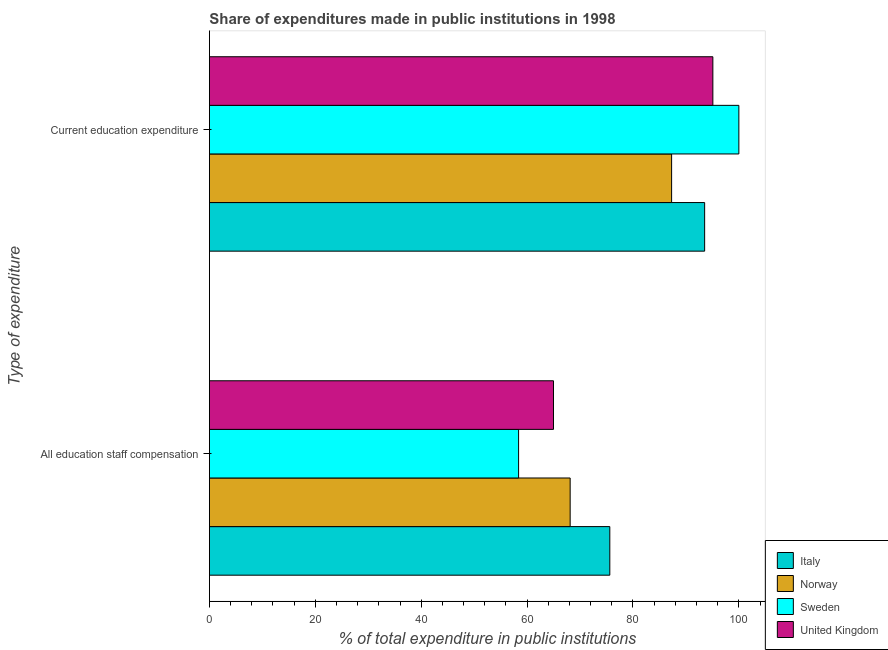How many groups of bars are there?
Your response must be concise. 2. How many bars are there on the 1st tick from the top?
Your answer should be very brief. 4. How many bars are there on the 2nd tick from the bottom?
Provide a short and direct response. 4. What is the label of the 2nd group of bars from the top?
Offer a very short reply. All education staff compensation. What is the expenditure in education in United Kingdom?
Make the answer very short. 95.09. Across all countries, what is the minimum expenditure in education?
Your response must be concise. 87.3. In which country was the expenditure in education minimum?
Your answer should be very brief. Norway. What is the total expenditure in staff compensation in the graph?
Make the answer very short. 267.14. What is the difference between the expenditure in staff compensation in Italy and that in United Kingdom?
Your answer should be very brief. 10.64. What is the difference between the expenditure in staff compensation in Italy and the expenditure in education in Sweden?
Provide a short and direct response. -24.37. What is the average expenditure in education per country?
Provide a succinct answer. 93.98. What is the difference between the expenditure in education and expenditure in staff compensation in Italy?
Your answer should be very brief. 17.91. What is the ratio of the expenditure in education in Norway to that in United Kingdom?
Provide a short and direct response. 0.92. Is the expenditure in education in Italy less than that in Norway?
Your answer should be compact. No. What does the 1st bar from the top in Current education expenditure represents?
Provide a short and direct response. United Kingdom. What does the 3rd bar from the bottom in Current education expenditure represents?
Your answer should be very brief. Sweden. How many countries are there in the graph?
Your response must be concise. 4. Are the values on the major ticks of X-axis written in scientific E-notation?
Your response must be concise. No. Does the graph contain any zero values?
Your answer should be compact. No. Does the graph contain grids?
Make the answer very short. No. Where does the legend appear in the graph?
Give a very brief answer. Bottom right. How many legend labels are there?
Ensure brevity in your answer.  4. How are the legend labels stacked?
Ensure brevity in your answer.  Vertical. What is the title of the graph?
Ensure brevity in your answer.  Share of expenditures made in public institutions in 1998. What is the label or title of the X-axis?
Ensure brevity in your answer.  % of total expenditure in public institutions. What is the label or title of the Y-axis?
Your answer should be compact. Type of expenditure. What is the % of total expenditure in public institutions of Italy in All education staff compensation?
Offer a terse response. 75.63. What is the % of total expenditure in public institutions in Norway in All education staff compensation?
Your answer should be compact. 68.14. What is the % of total expenditure in public institutions in Sweden in All education staff compensation?
Give a very brief answer. 58.4. What is the % of total expenditure in public institutions in United Kingdom in All education staff compensation?
Your response must be concise. 64.98. What is the % of total expenditure in public institutions in Italy in Current education expenditure?
Provide a short and direct response. 93.54. What is the % of total expenditure in public institutions of Norway in Current education expenditure?
Make the answer very short. 87.3. What is the % of total expenditure in public institutions in Sweden in Current education expenditure?
Keep it short and to the point. 100. What is the % of total expenditure in public institutions in United Kingdom in Current education expenditure?
Offer a terse response. 95.09. Across all Type of expenditure, what is the maximum % of total expenditure in public institutions of Italy?
Ensure brevity in your answer.  93.54. Across all Type of expenditure, what is the maximum % of total expenditure in public institutions of Norway?
Provide a short and direct response. 87.3. Across all Type of expenditure, what is the maximum % of total expenditure in public institutions in Sweden?
Keep it short and to the point. 100. Across all Type of expenditure, what is the maximum % of total expenditure in public institutions of United Kingdom?
Provide a succinct answer. 95.09. Across all Type of expenditure, what is the minimum % of total expenditure in public institutions of Italy?
Your response must be concise. 75.63. Across all Type of expenditure, what is the minimum % of total expenditure in public institutions in Norway?
Make the answer very short. 68.14. Across all Type of expenditure, what is the minimum % of total expenditure in public institutions in Sweden?
Keep it short and to the point. 58.4. Across all Type of expenditure, what is the minimum % of total expenditure in public institutions in United Kingdom?
Offer a very short reply. 64.98. What is the total % of total expenditure in public institutions of Italy in the graph?
Provide a short and direct response. 169.16. What is the total % of total expenditure in public institutions of Norway in the graph?
Your response must be concise. 155.43. What is the total % of total expenditure in public institutions of Sweden in the graph?
Provide a succinct answer. 158.4. What is the total % of total expenditure in public institutions in United Kingdom in the graph?
Your answer should be very brief. 160.07. What is the difference between the % of total expenditure in public institutions in Italy in All education staff compensation and that in Current education expenditure?
Keep it short and to the point. -17.91. What is the difference between the % of total expenditure in public institutions of Norway in All education staff compensation and that in Current education expenditure?
Provide a short and direct response. -19.16. What is the difference between the % of total expenditure in public institutions in Sweden in All education staff compensation and that in Current education expenditure?
Make the answer very short. -41.6. What is the difference between the % of total expenditure in public institutions in United Kingdom in All education staff compensation and that in Current education expenditure?
Your response must be concise. -30.1. What is the difference between the % of total expenditure in public institutions in Italy in All education staff compensation and the % of total expenditure in public institutions in Norway in Current education expenditure?
Give a very brief answer. -11.67. What is the difference between the % of total expenditure in public institutions in Italy in All education staff compensation and the % of total expenditure in public institutions in Sweden in Current education expenditure?
Your response must be concise. -24.37. What is the difference between the % of total expenditure in public institutions of Italy in All education staff compensation and the % of total expenditure in public institutions of United Kingdom in Current education expenditure?
Offer a very short reply. -19.46. What is the difference between the % of total expenditure in public institutions in Norway in All education staff compensation and the % of total expenditure in public institutions in Sweden in Current education expenditure?
Provide a short and direct response. -31.86. What is the difference between the % of total expenditure in public institutions of Norway in All education staff compensation and the % of total expenditure in public institutions of United Kingdom in Current education expenditure?
Provide a succinct answer. -26.95. What is the difference between the % of total expenditure in public institutions in Sweden in All education staff compensation and the % of total expenditure in public institutions in United Kingdom in Current education expenditure?
Provide a short and direct response. -36.69. What is the average % of total expenditure in public institutions in Italy per Type of expenditure?
Ensure brevity in your answer.  84.58. What is the average % of total expenditure in public institutions in Norway per Type of expenditure?
Offer a terse response. 77.72. What is the average % of total expenditure in public institutions in Sweden per Type of expenditure?
Keep it short and to the point. 79.2. What is the average % of total expenditure in public institutions of United Kingdom per Type of expenditure?
Your answer should be compact. 80.04. What is the difference between the % of total expenditure in public institutions in Italy and % of total expenditure in public institutions in Norway in All education staff compensation?
Your answer should be very brief. 7.49. What is the difference between the % of total expenditure in public institutions in Italy and % of total expenditure in public institutions in Sweden in All education staff compensation?
Ensure brevity in your answer.  17.23. What is the difference between the % of total expenditure in public institutions in Italy and % of total expenditure in public institutions in United Kingdom in All education staff compensation?
Ensure brevity in your answer.  10.64. What is the difference between the % of total expenditure in public institutions in Norway and % of total expenditure in public institutions in Sweden in All education staff compensation?
Provide a succinct answer. 9.74. What is the difference between the % of total expenditure in public institutions of Norway and % of total expenditure in public institutions of United Kingdom in All education staff compensation?
Your answer should be very brief. 3.15. What is the difference between the % of total expenditure in public institutions in Sweden and % of total expenditure in public institutions in United Kingdom in All education staff compensation?
Ensure brevity in your answer.  -6.59. What is the difference between the % of total expenditure in public institutions of Italy and % of total expenditure in public institutions of Norway in Current education expenditure?
Make the answer very short. 6.24. What is the difference between the % of total expenditure in public institutions in Italy and % of total expenditure in public institutions in Sweden in Current education expenditure?
Make the answer very short. -6.46. What is the difference between the % of total expenditure in public institutions of Italy and % of total expenditure in public institutions of United Kingdom in Current education expenditure?
Ensure brevity in your answer.  -1.55. What is the difference between the % of total expenditure in public institutions in Norway and % of total expenditure in public institutions in Sweden in Current education expenditure?
Keep it short and to the point. -12.7. What is the difference between the % of total expenditure in public institutions of Norway and % of total expenditure in public institutions of United Kingdom in Current education expenditure?
Make the answer very short. -7.79. What is the difference between the % of total expenditure in public institutions in Sweden and % of total expenditure in public institutions in United Kingdom in Current education expenditure?
Make the answer very short. 4.91. What is the ratio of the % of total expenditure in public institutions in Italy in All education staff compensation to that in Current education expenditure?
Provide a short and direct response. 0.81. What is the ratio of the % of total expenditure in public institutions in Norway in All education staff compensation to that in Current education expenditure?
Ensure brevity in your answer.  0.78. What is the ratio of the % of total expenditure in public institutions of Sweden in All education staff compensation to that in Current education expenditure?
Provide a short and direct response. 0.58. What is the ratio of the % of total expenditure in public institutions in United Kingdom in All education staff compensation to that in Current education expenditure?
Your answer should be very brief. 0.68. What is the difference between the highest and the second highest % of total expenditure in public institutions of Italy?
Offer a very short reply. 17.91. What is the difference between the highest and the second highest % of total expenditure in public institutions in Norway?
Ensure brevity in your answer.  19.16. What is the difference between the highest and the second highest % of total expenditure in public institutions in Sweden?
Make the answer very short. 41.6. What is the difference between the highest and the second highest % of total expenditure in public institutions of United Kingdom?
Ensure brevity in your answer.  30.1. What is the difference between the highest and the lowest % of total expenditure in public institutions in Italy?
Your answer should be very brief. 17.91. What is the difference between the highest and the lowest % of total expenditure in public institutions of Norway?
Make the answer very short. 19.16. What is the difference between the highest and the lowest % of total expenditure in public institutions of Sweden?
Provide a succinct answer. 41.6. What is the difference between the highest and the lowest % of total expenditure in public institutions of United Kingdom?
Ensure brevity in your answer.  30.1. 